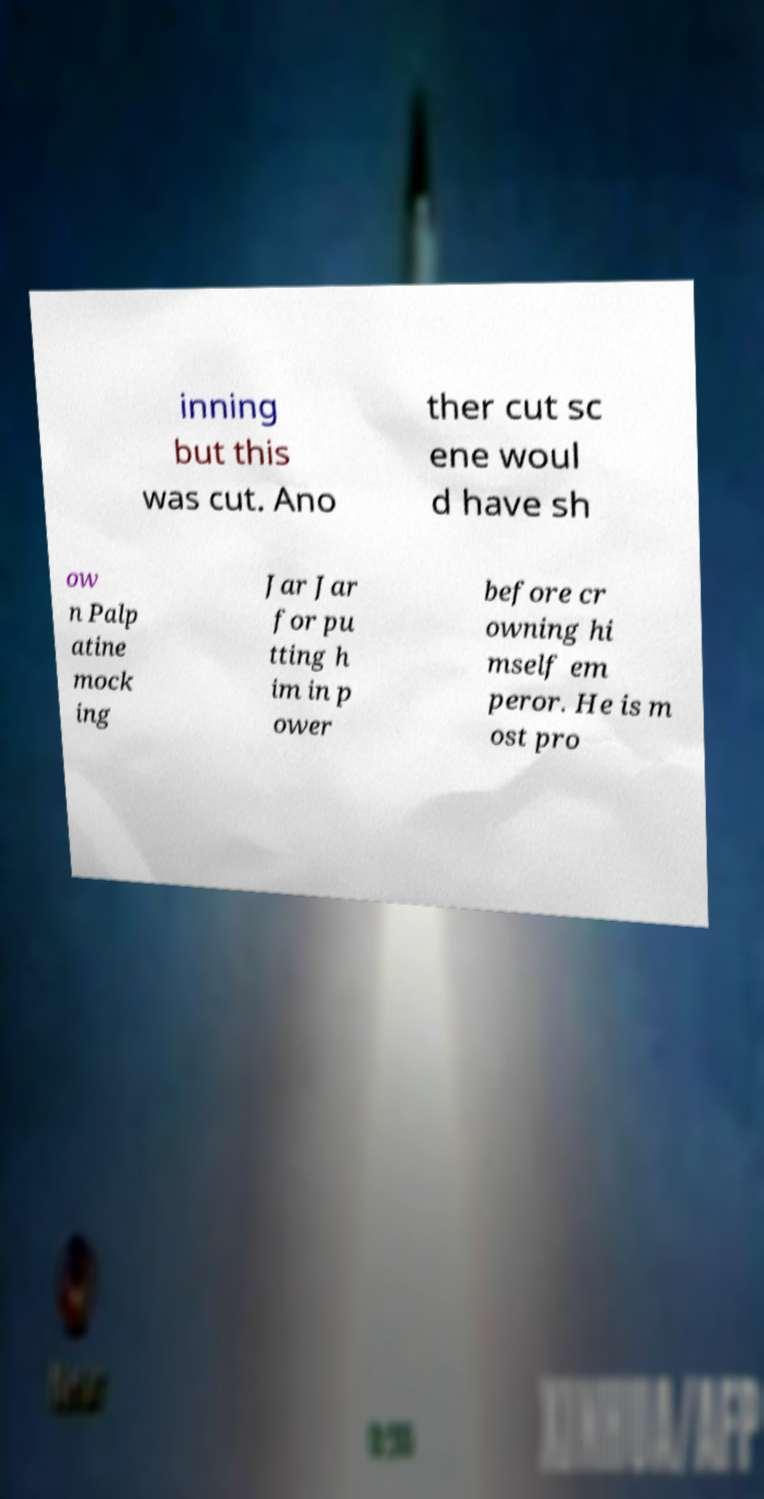Could you extract and type out the text from this image? inning but this was cut. Ano ther cut sc ene woul d have sh ow n Palp atine mock ing Jar Jar for pu tting h im in p ower before cr owning hi mself em peror. He is m ost pro 